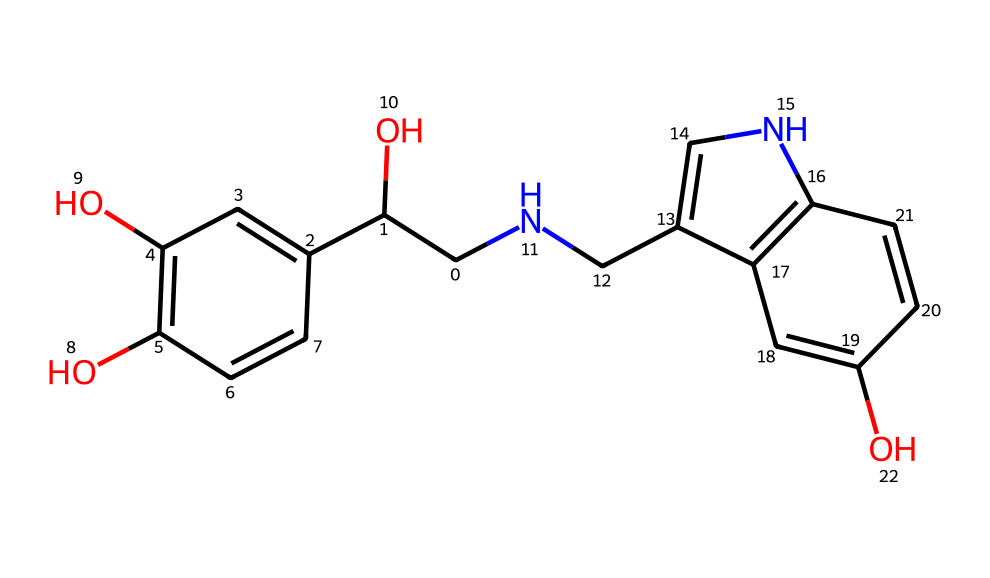how many carbon atoms are in the structure? By analyzing the SMILES representation, we count the number of carbon atoms represented. The 'C' letters in the SMILES indicate carbon, and by counting them, we find a total of 14 carbon atoms.
Answer: 14 what is the main functional group present in this compound? The structure contains a hydroxyl group (-OH) as denoted by the 'O' in the SMILES and its proximity to carbon atoms, indicating alcohol functional groups. Since there are multiple 'O' atoms, it is identified as a phenolic compound with hydroxyl groups.
Answer: hydroxyl is this compound chiral? To determine chirality, we look for carbon atoms attached to four different substituents (chiral centers). In this structure, at least one carbon center meets this criterion, confirming its chiral nature.
Answer: yes what is the molecular weight of adrenaline? Based on the molecular formula derived from the SMILES notation (C14H17N2O5), we calculate the molecular weight by adding the weight of each constituent atom: (14 * 12.01) + (17 * 1.008) + (2 * 14.01) + (5 * 16.00) = 183.23 g/mol.
Answer: 183.23 how many rings are present in this compound? By examining the structure, we notice that there are two separate ring systems indicated by 'c' in the SMILES, denoting aromatic rings. This confirms the presence of two rings in the overall structure.
Answer: 2 which part of this molecule is associated with the body's fight-or-flight response? The structure of adrenaline has a specific part that includes the amine group (-NH) which is crucial for its function in the adrenal response. This helps it interact with adrenergic receptors, impacting physiological responses.
Answer: amine group 